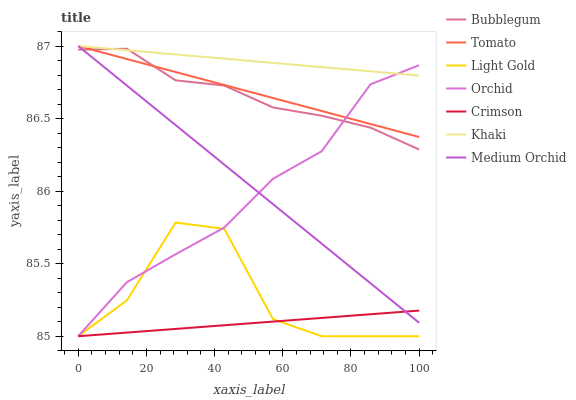Does Crimson have the minimum area under the curve?
Answer yes or no. Yes. Does Khaki have the maximum area under the curve?
Answer yes or no. Yes. Does Medium Orchid have the minimum area under the curve?
Answer yes or no. No. Does Medium Orchid have the maximum area under the curve?
Answer yes or no. No. Is Tomato the smoothest?
Answer yes or no. Yes. Is Light Gold the roughest?
Answer yes or no. Yes. Is Khaki the smoothest?
Answer yes or no. No. Is Khaki the roughest?
Answer yes or no. No. Does Crimson have the lowest value?
Answer yes or no. Yes. Does Medium Orchid have the lowest value?
Answer yes or no. No. Does Medium Orchid have the highest value?
Answer yes or no. Yes. Does Bubblegum have the highest value?
Answer yes or no. No. Is Light Gold less than Khaki?
Answer yes or no. Yes. Is Khaki greater than Crimson?
Answer yes or no. Yes. Does Tomato intersect Khaki?
Answer yes or no. Yes. Is Tomato less than Khaki?
Answer yes or no. No. Is Tomato greater than Khaki?
Answer yes or no. No. Does Light Gold intersect Khaki?
Answer yes or no. No. 